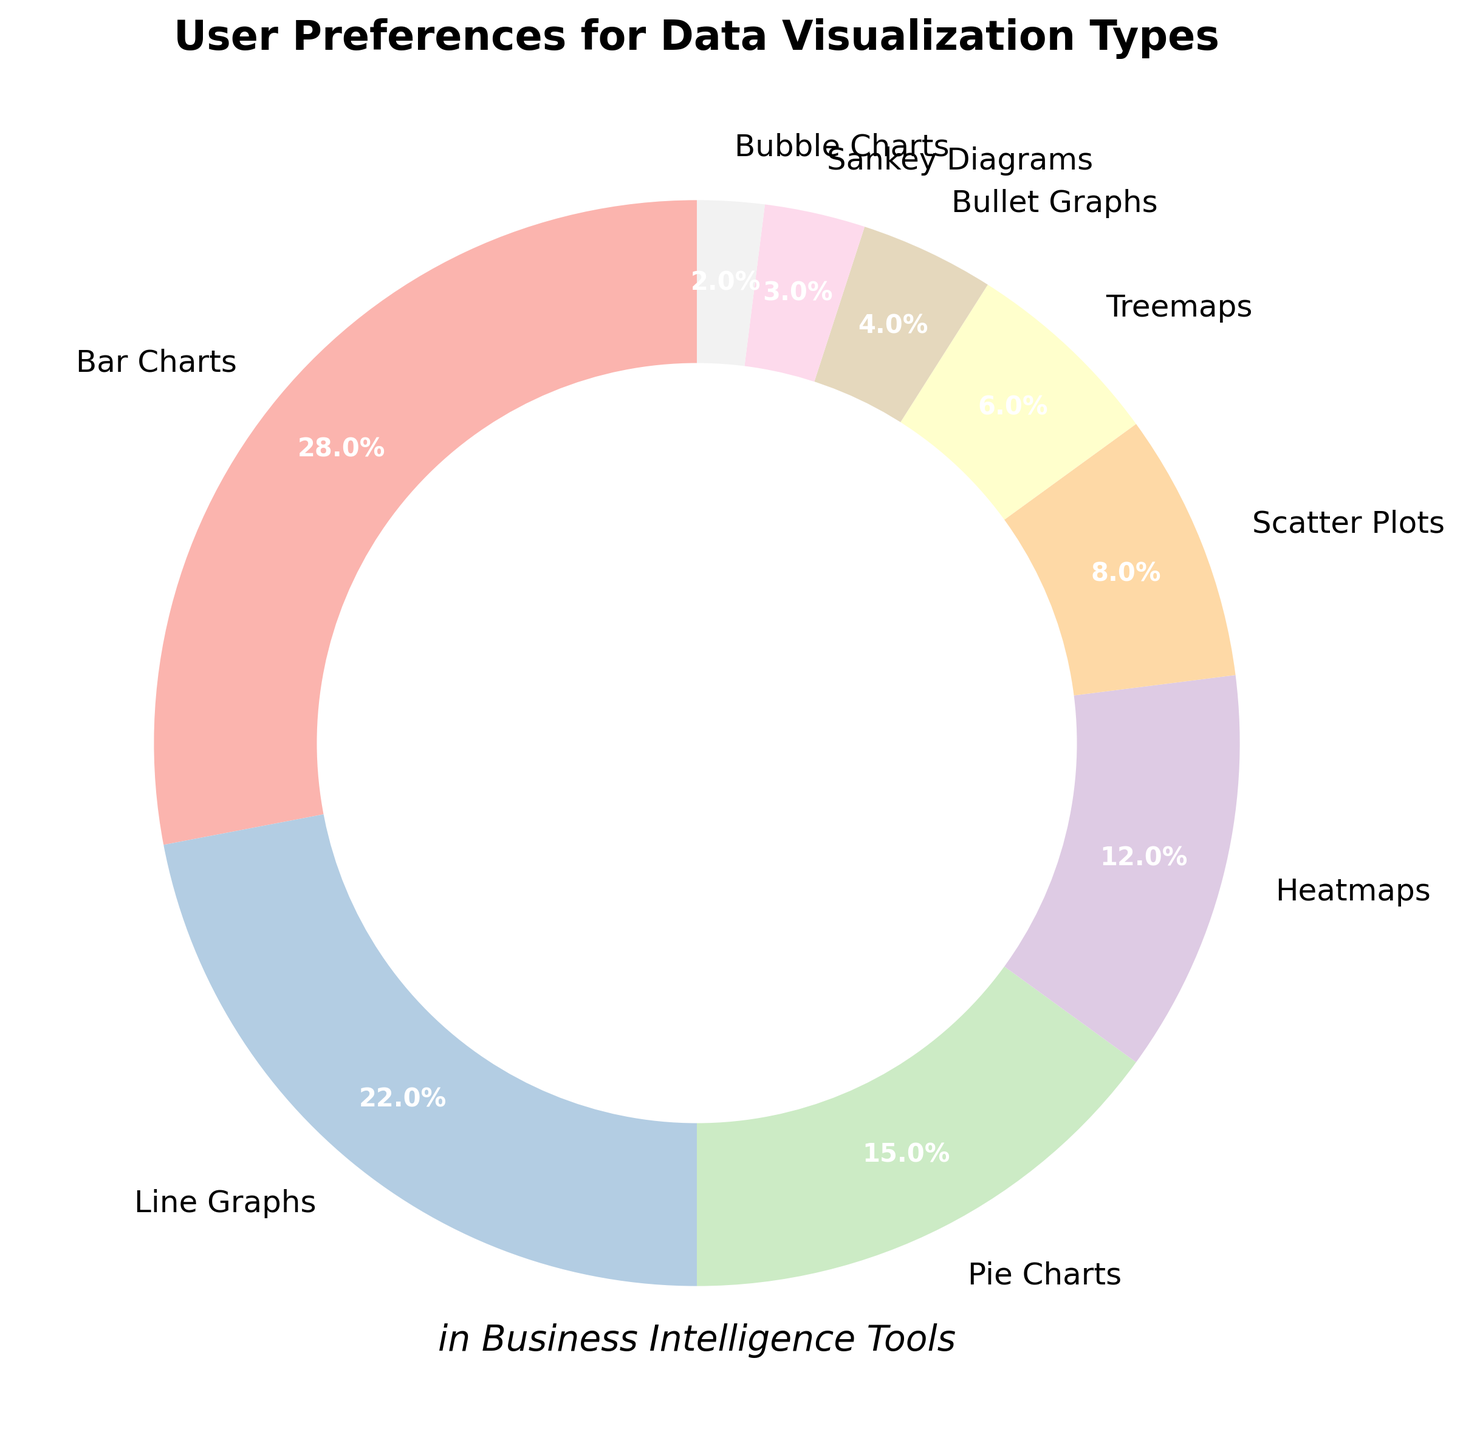Which visualization type has the highest user preference? The pie chart shows the different visualization types and their corresponding user preferences as percentages. Bar Charts segment is the largest with 28%.
Answer: Bar Charts Which visualization type has the lowest user preference? The pie chart displays various segments with percentages indicating user preferences. The smallest segment is Bubble Charts with 2%.
Answer: Bubble Charts What is the combined percentage for Heatmaps and Scatter Plots? Heatmaps have 12% and Scatter Plots have 8%. Adding these together: 12% + 8% = 20%.
Answer: 20% How much higher is the preference for Line Graphs compared to Bullet Graphs? Line Graphs have a preference of 22% and Bullet Graphs have 4%. The difference is 22% - 4% = 18%.
Answer: 18% Rank the top three visualization types by user preference. The pie chart shows percentages for each visualization type. The top three are Bar Charts (28%), Line Graphs (22%), and Pie Charts (15%).
Answer: Bar Charts, Line Graphs, Pie Charts What is the difference in user preference between Treemaps and Sankey Diagrams? Treemaps have a preference of 6% and Sankey Diagrams have 3%. The difference is 6% - 3% = 3%.
Answer: 3% Are there more users who prefer Heatmaps or Pie Charts? Heatmaps have 12% while Pie Charts have 15%. Comparing these, Pie Charts have a higher preference.
Answer: Pie Charts What percentage of users prefer either Bar Charts or Line Graphs? Bar Charts have 28% and Line Graphs have 22%. Combined, this is 28% + 22% = 50%.
Answer: 50% If you combined the preferences of Scatter Plots, Treemaps, and Bullet Graphs, what would that total percentage be? Scatter Plots have 8%, Treemaps have 6%, and Bullet Graphs have 4%. Adding these together: 8% + 6% + 4% = 18%.
Answer: 18% How much more popular are Bar Charts than Heatmaps? Bar Charts have 28% and Heatmaps have 12%. The difference is 28% - 12% = 16%.
Answer: 16% 